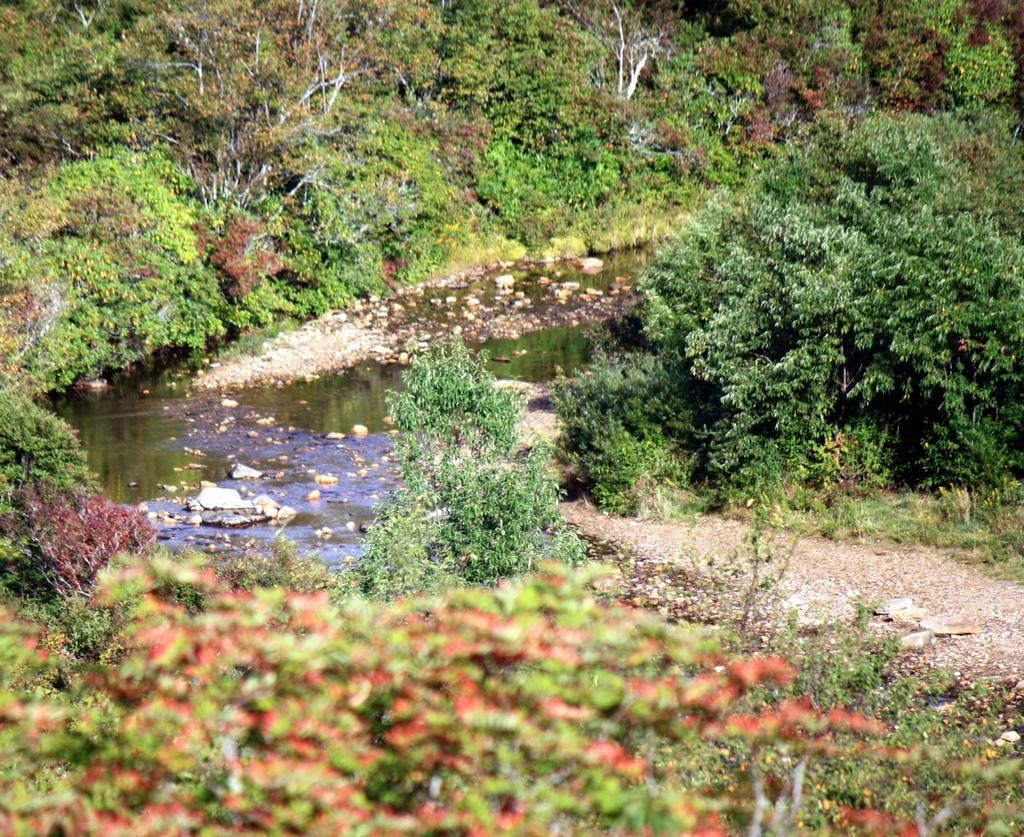What type of vegetation can be seen in the image? There are many plants and trees in the image. What other elements can be seen in the image besides vegetation? There are stones, water, and land visible in the image. What type of pies are being baked in the image? There are no pies present in the image; it features plants, trees, stones, water, and land. What process is being carried out in the image? The image does not depict a specific process; it is a scene of natural elements. 